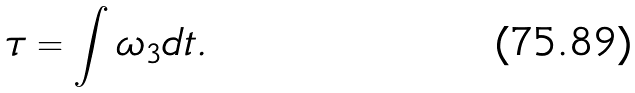Convert formula to latex. <formula><loc_0><loc_0><loc_500><loc_500>\tau = \int { \omega _ { 3 } } d t .</formula> 